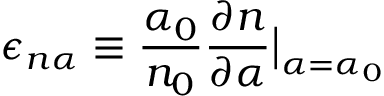<formula> <loc_0><loc_0><loc_500><loc_500>\epsilon _ { n \alpha } \equiv \frac { \alpha _ { 0 } } { n _ { 0 } } \frac { \partial n } { \partial \alpha } \Big | _ { \alpha = \alpha _ { 0 } }</formula> 